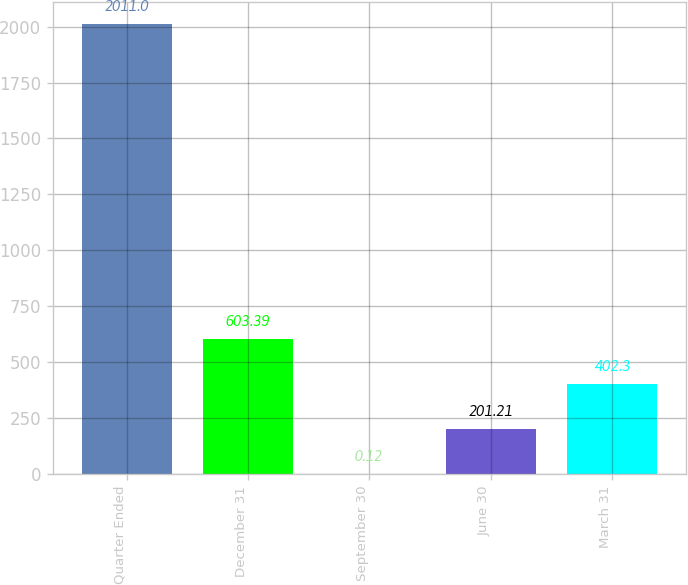Convert chart to OTSL. <chart><loc_0><loc_0><loc_500><loc_500><bar_chart><fcel>Quarter Ended<fcel>December 31<fcel>September 30<fcel>June 30<fcel>March 31<nl><fcel>2011<fcel>603.39<fcel>0.12<fcel>201.21<fcel>402.3<nl></chart> 